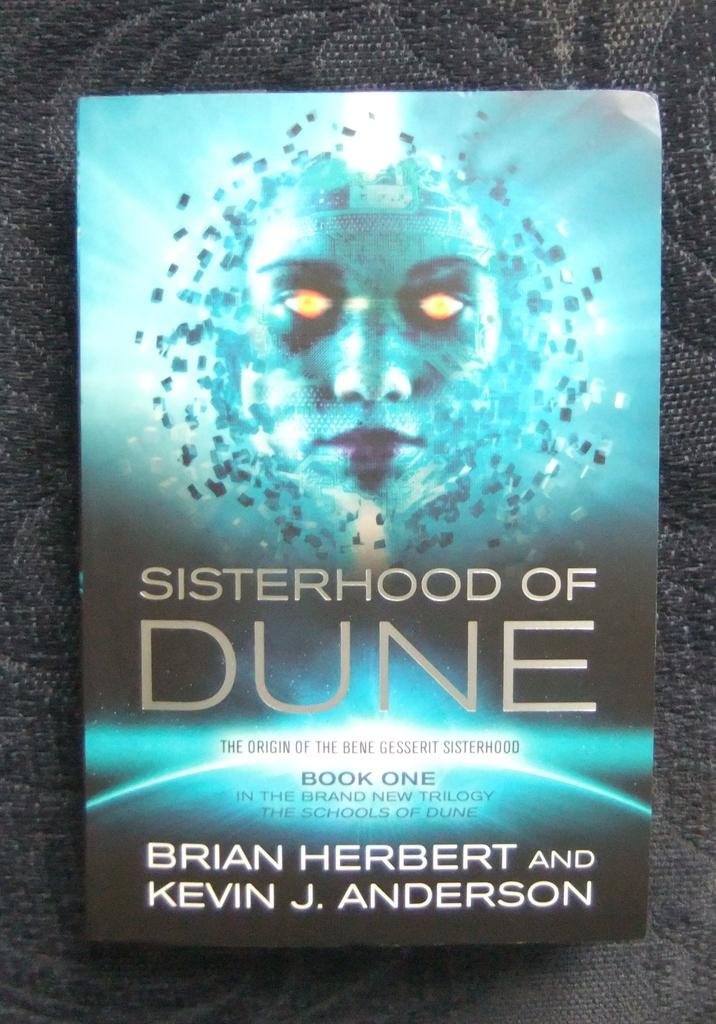What's the title of the book?
Provide a succinct answer. Sisterhood of dune. 